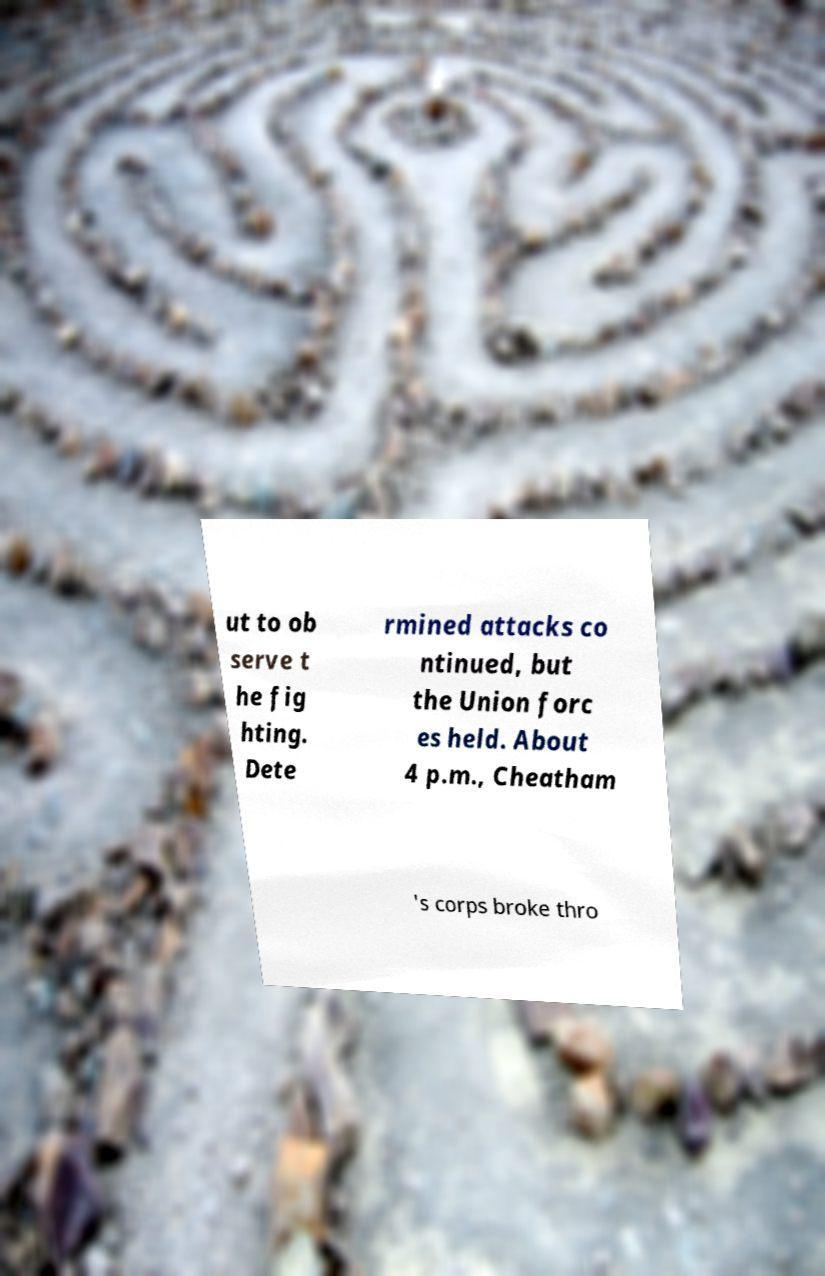Can you read and provide the text displayed in the image?This photo seems to have some interesting text. Can you extract and type it out for me? ut to ob serve t he fig hting. Dete rmined attacks co ntinued, but the Union forc es held. About 4 p.m., Cheatham 's corps broke thro 